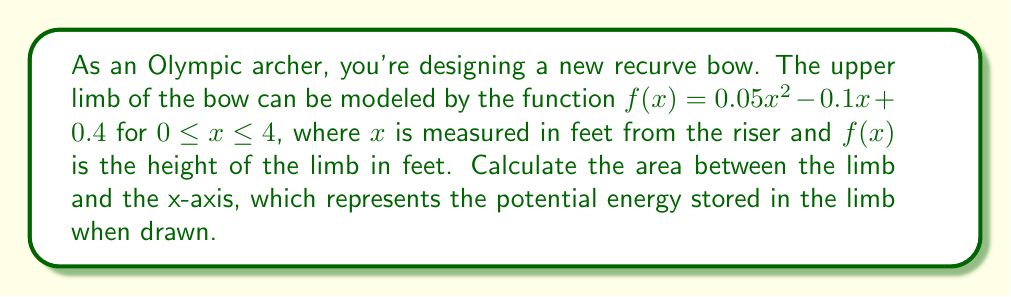Help me with this question. To find the area between the limb curve and the x-axis, we need to integrate the function $f(x)$ over the given interval. This area represents the potential energy stored in the limb when drawn.

Step 1: Set up the definite integral
$$A = \int_0^4 f(x) dx = \int_0^4 (0.05x^2 - 0.1x + 0.4) dx$$

Step 2: Integrate the function
$$\begin{align*}
A &= \int_0^4 (0.05x^2 - 0.1x + 0.4) dx \\
&= \left[\frac{0.05x^3}{3} - \frac{0.1x^2}{2} + 0.4x\right]_0^4
\end{align*}$$

Step 3: Evaluate the integral at the bounds
$$\begin{align*}
A &= \left(\frac{0.05(4^3)}{3} - \frac{0.1(4^2)}{2} + 0.4(4)\right) - \left(\frac{0.05(0^3)}{3} - \frac{0.1(0^2)}{2} + 0.4(0)\right) \\
&= \left(\frac{3.2}{3} - 0.8 + 1.6\right) - (0) \\
&= 1.0667 - 0.8 + 1.6 \\
&= 1.8667
\end{align*}$$

Therefore, the area between the limb curve and the x-axis is approximately 1.8667 square feet.
Answer: The area between the limb curve and the x-axis, representing the potential energy stored in the limb when drawn, is approximately 1.8667 square feet. 